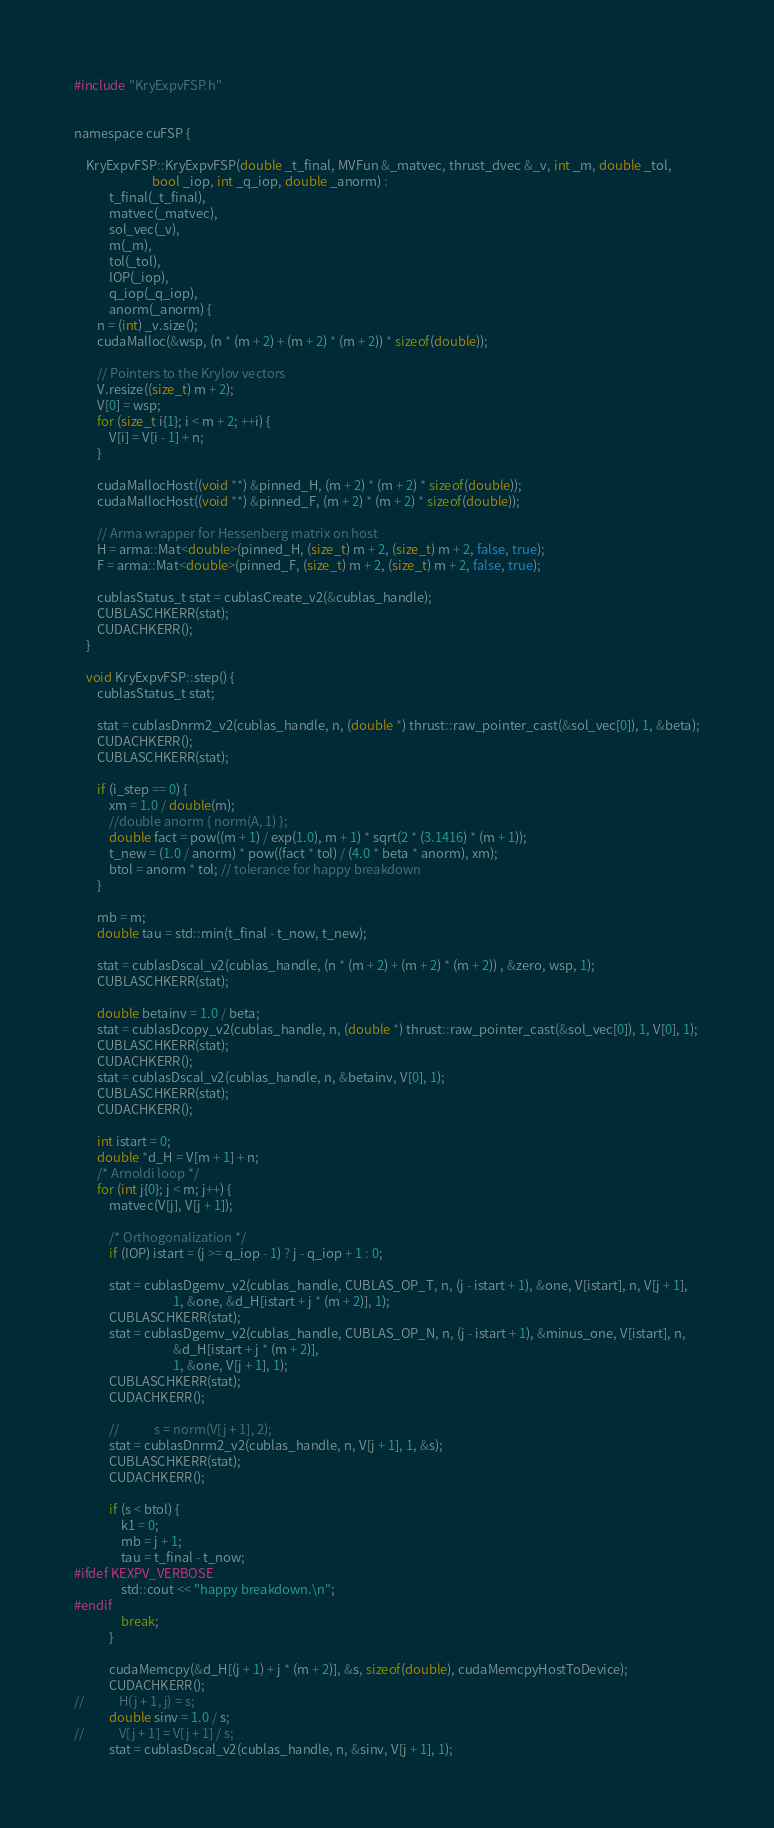<code> <loc_0><loc_0><loc_500><loc_500><_Cuda_>#include "KryExpvFSP.h"


namespace cuFSP {

    KryExpvFSP::KryExpvFSP(double _t_final, MVFun &_matvec, thrust_dvec &_v, int _m, double _tol,
                           bool _iop, int _q_iop, double _anorm) :
            t_final(_t_final),
            matvec(_matvec),
            sol_vec(_v),
            m(_m),
            tol(_tol),
            IOP(_iop),
            q_iop(_q_iop),
            anorm(_anorm) {
        n = (int) _v.size();
        cudaMalloc(&wsp, (n * (m + 2) + (m + 2) * (m + 2)) * sizeof(double));

        // Pointers to the Krylov vectors
        V.resize((size_t) m + 2);
        V[0] = wsp;
        for (size_t i{1}; i < m + 2; ++i) {
            V[i] = V[i - 1] + n;
        }

        cudaMallocHost((void **) &pinned_H, (m + 2) * (m + 2) * sizeof(double));
        cudaMallocHost((void **) &pinned_F, (m + 2) * (m + 2) * sizeof(double));

        // Arma wrapper for Hessenberg matrix on host
        H = arma::Mat<double>(pinned_H, (size_t) m + 2, (size_t) m + 2, false, true);
        F = arma::Mat<double>(pinned_F, (size_t) m + 2, (size_t) m + 2, false, true);

        cublasStatus_t stat = cublasCreate_v2(&cublas_handle);
        CUBLASCHKERR(stat);
        CUDACHKERR();
    }

    void KryExpvFSP::step() {
        cublasStatus_t stat;

        stat = cublasDnrm2_v2(cublas_handle, n, (double *) thrust::raw_pointer_cast(&sol_vec[0]), 1, &beta);
        CUDACHKERR();
        CUBLASCHKERR(stat);

        if (i_step == 0) {
            xm = 1.0 / double(m);
            //double anorm { norm(A, 1) };
            double fact = pow((m + 1) / exp(1.0), m + 1) * sqrt(2 * (3.1416) * (m + 1));
            t_new = (1.0 / anorm) * pow((fact * tol) / (4.0 * beta * anorm), xm);
            btol = anorm * tol; // tolerance for happy breakdown
        }

        mb = m;
        double tau = std::min(t_final - t_now, t_new);

        stat = cublasDscal_v2(cublas_handle, (n * (m + 2) + (m + 2) * (m + 2)) , &zero, wsp, 1);
        CUBLASCHKERR(stat);

        double betainv = 1.0 / beta;
        stat = cublasDcopy_v2(cublas_handle, n, (double *) thrust::raw_pointer_cast(&sol_vec[0]), 1, V[0], 1);
        CUBLASCHKERR(stat);
        CUDACHKERR();
        stat = cublasDscal_v2(cublas_handle, n, &betainv, V[0], 1);
        CUBLASCHKERR(stat);
        CUDACHKERR();

        int istart = 0;
        double *d_H = V[m + 1] + n;
        /* Arnoldi loop */
        for (int j{0}; j < m; j++) {
            matvec(V[j], V[j + 1]);

            /* Orthogonalization */
            if (IOP) istart = (j >= q_iop - 1) ? j - q_iop + 1 : 0;

            stat = cublasDgemv_v2(cublas_handle, CUBLAS_OP_T, n, (j - istart + 1), &one, V[istart], n, V[j + 1],
                                  1, &one, &d_H[istart + j * (m + 2)], 1);
            CUBLASCHKERR(stat);
            stat = cublasDgemv_v2(cublas_handle, CUBLAS_OP_N, n, (j - istart + 1), &minus_one, V[istart], n,
                                  &d_H[istart + j * (m + 2)],
                                  1, &one, V[j + 1], 1);
            CUBLASCHKERR(stat);
            CUDACHKERR();

            //            s = norm(V[j + 1], 2);
            stat = cublasDnrm2_v2(cublas_handle, n, V[j + 1], 1, &s);
            CUBLASCHKERR(stat);
            CUDACHKERR();

            if (s < btol) {
                k1 = 0;
                mb = j + 1;
                tau = t_final - t_now;
#ifdef KEXPV_VERBOSE
                std::cout << "happy breakdown.\n";
#endif
                break;
            }

            cudaMemcpy(&d_H[(j + 1) + j * (m + 2)], &s, sizeof(double), cudaMemcpyHostToDevice);
            CUDACHKERR();
//            H(j + 1, j) = s;
            double sinv = 1.0 / s;
//            V[j + 1] = V[j + 1] / s;
            stat = cublasDscal_v2(cublas_handle, n, &sinv, V[j + 1], 1);
</code> 